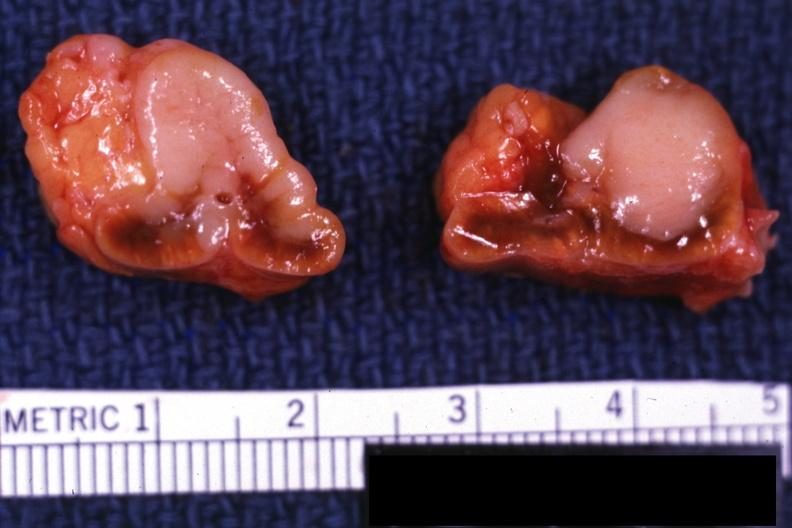s lateral view present?
Answer the question using a single word or phrase. No 